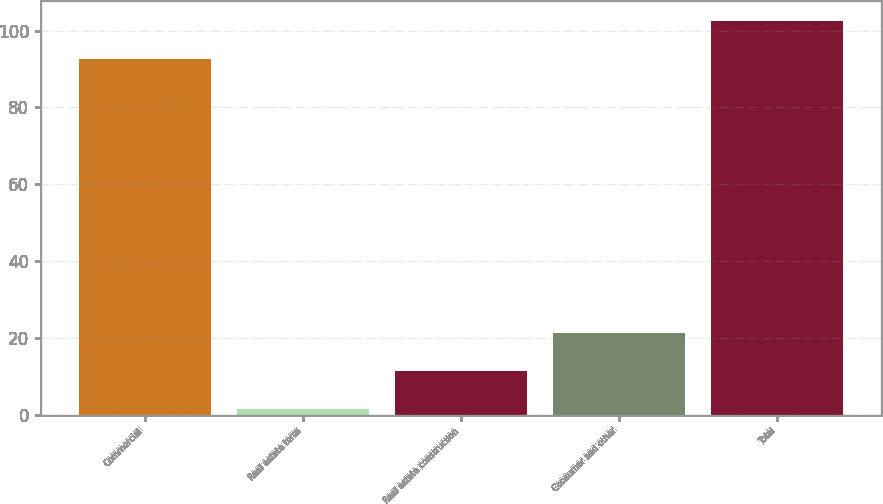Convert chart to OTSL. <chart><loc_0><loc_0><loc_500><loc_500><bar_chart><fcel>Commercial<fcel>Real estate term<fcel>Real estate construction<fcel>Consumer and other<fcel>Total<nl><fcel>92.7<fcel>1.4<fcel>11.26<fcel>21.12<fcel>102.56<nl></chart> 